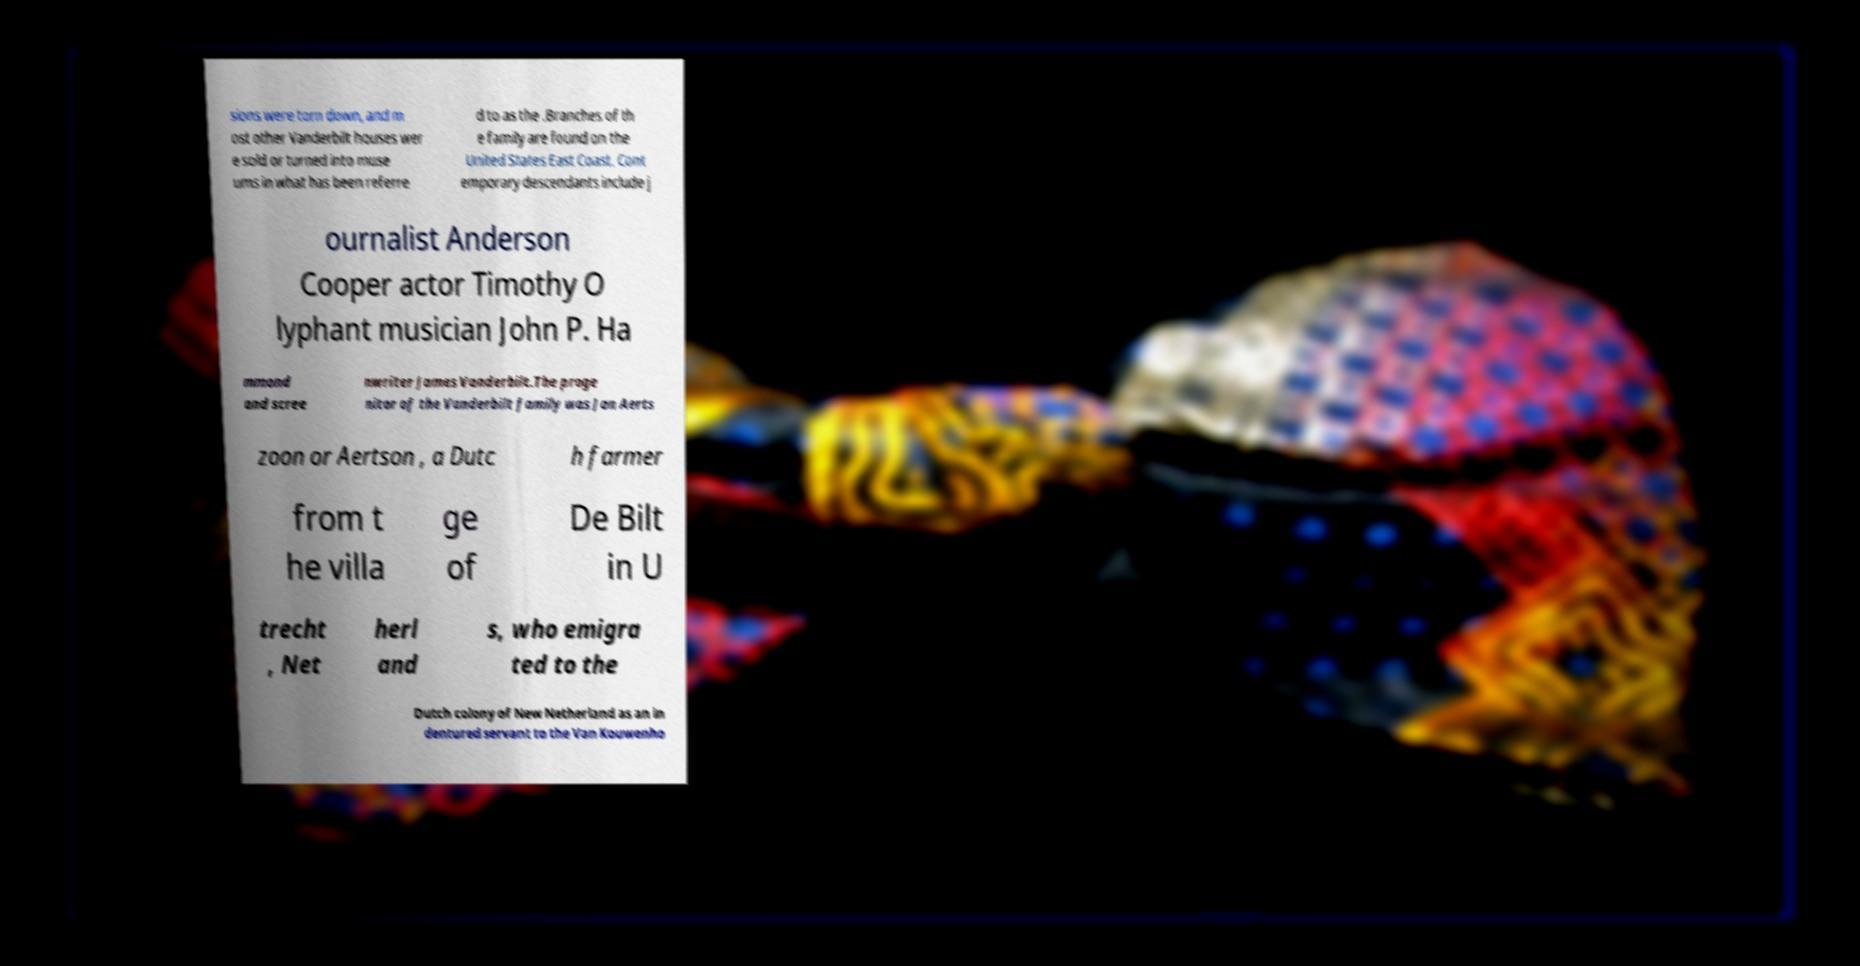Could you extract and type out the text from this image? sions were torn down, and m ost other Vanderbilt houses wer e sold or turned into muse ums in what has been referre d to as the .Branches of th e family are found on the United States East Coast. Cont emporary descendants include j ournalist Anderson Cooper actor Timothy O lyphant musician John P. Ha mmond and scree nwriter James Vanderbilt.The proge nitor of the Vanderbilt family was Jan Aerts zoon or Aertson , a Dutc h farmer from t he villa ge of De Bilt in U trecht , Net herl and s, who emigra ted to the Dutch colony of New Netherland as an in dentured servant to the Van Kouwenho 